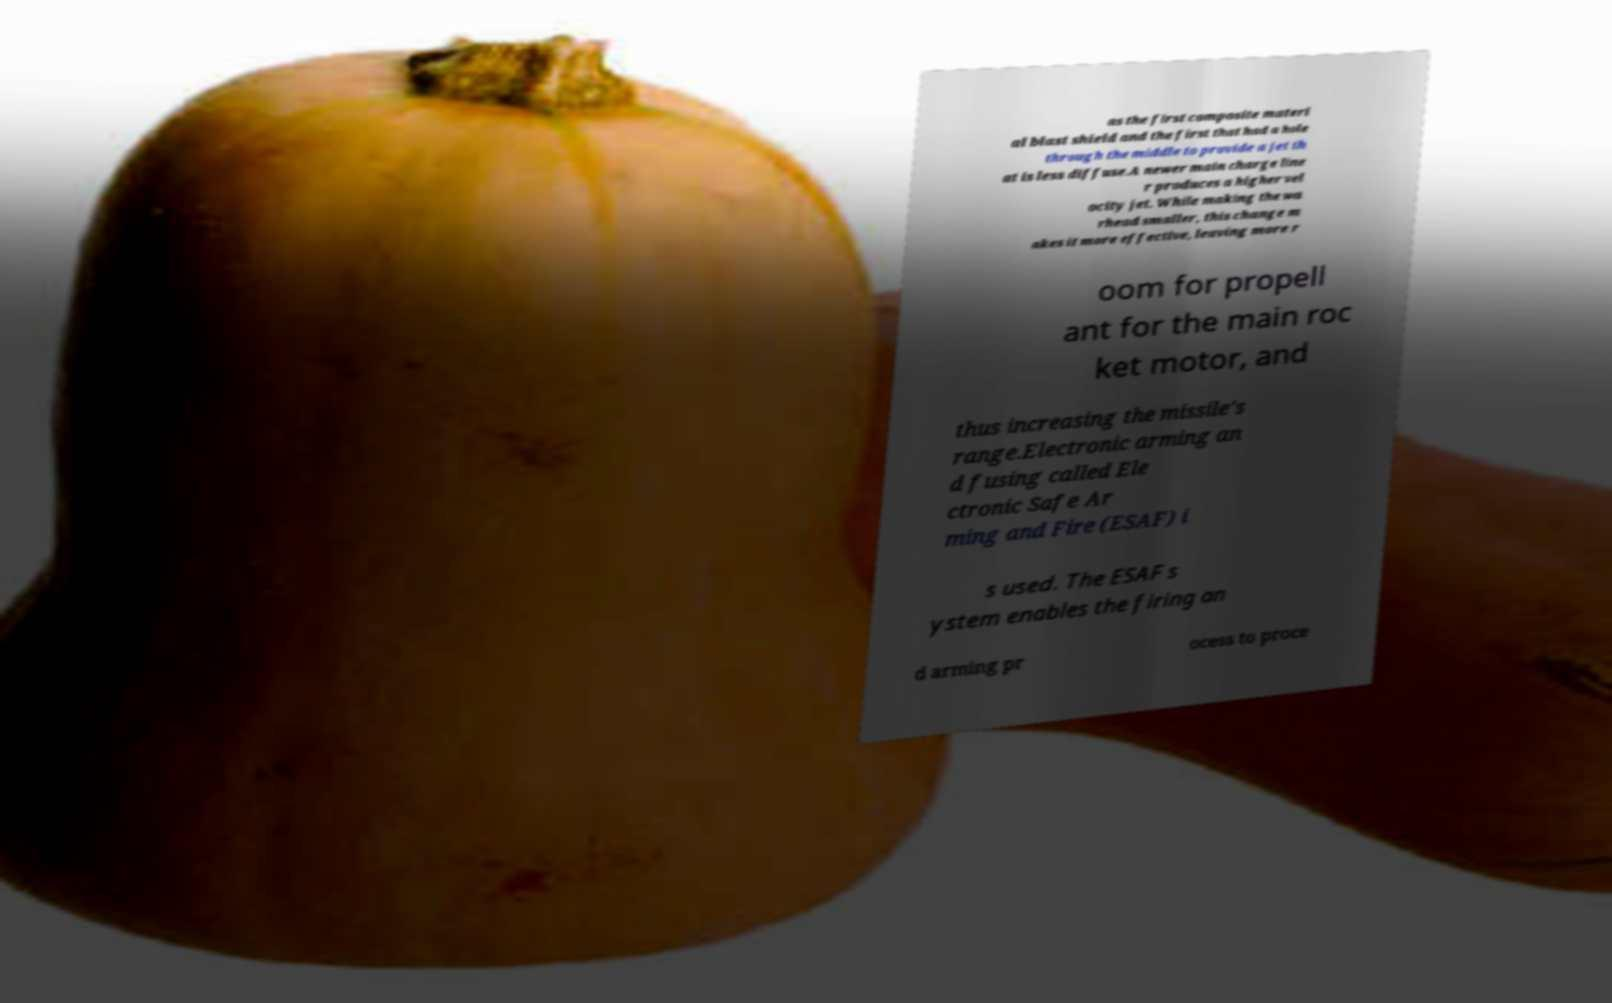Please read and relay the text visible in this image. What does it say? as the first composite materi al blast shield and the first that had a hole through the middle to provide a jet th at is less diffuse.A newer main charge line r produces a higher vel ocity jet. While making the wa rhead smaller, this change m akes it more effective, leaving more r oom for propell ant for the main roc ket motor, and thus increasing the missile's range.Electronic arming an d fusing called Ele ctronic Safe Ar ming and Fire (ESAF) i s used. The ESAF s ystem enables the firing an d arming pr ocess to proce 